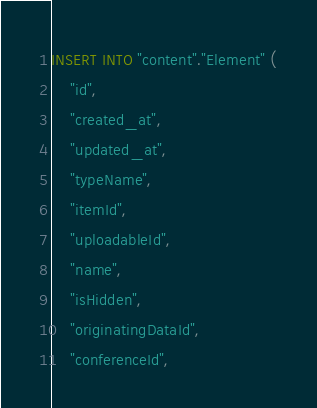<code> <loc_0><loc_0><loc_500><loc_500><_SQL_>INSERT INTO "content"."Element" (
    "id", 
    "created_at", 
    "updated_at", 
    "typeName", 
    "itemId", 
    "uploadableId", 
    "name", 
    "isHidden", 
    "originatingDataId", 
    "conferenceId", </code> 